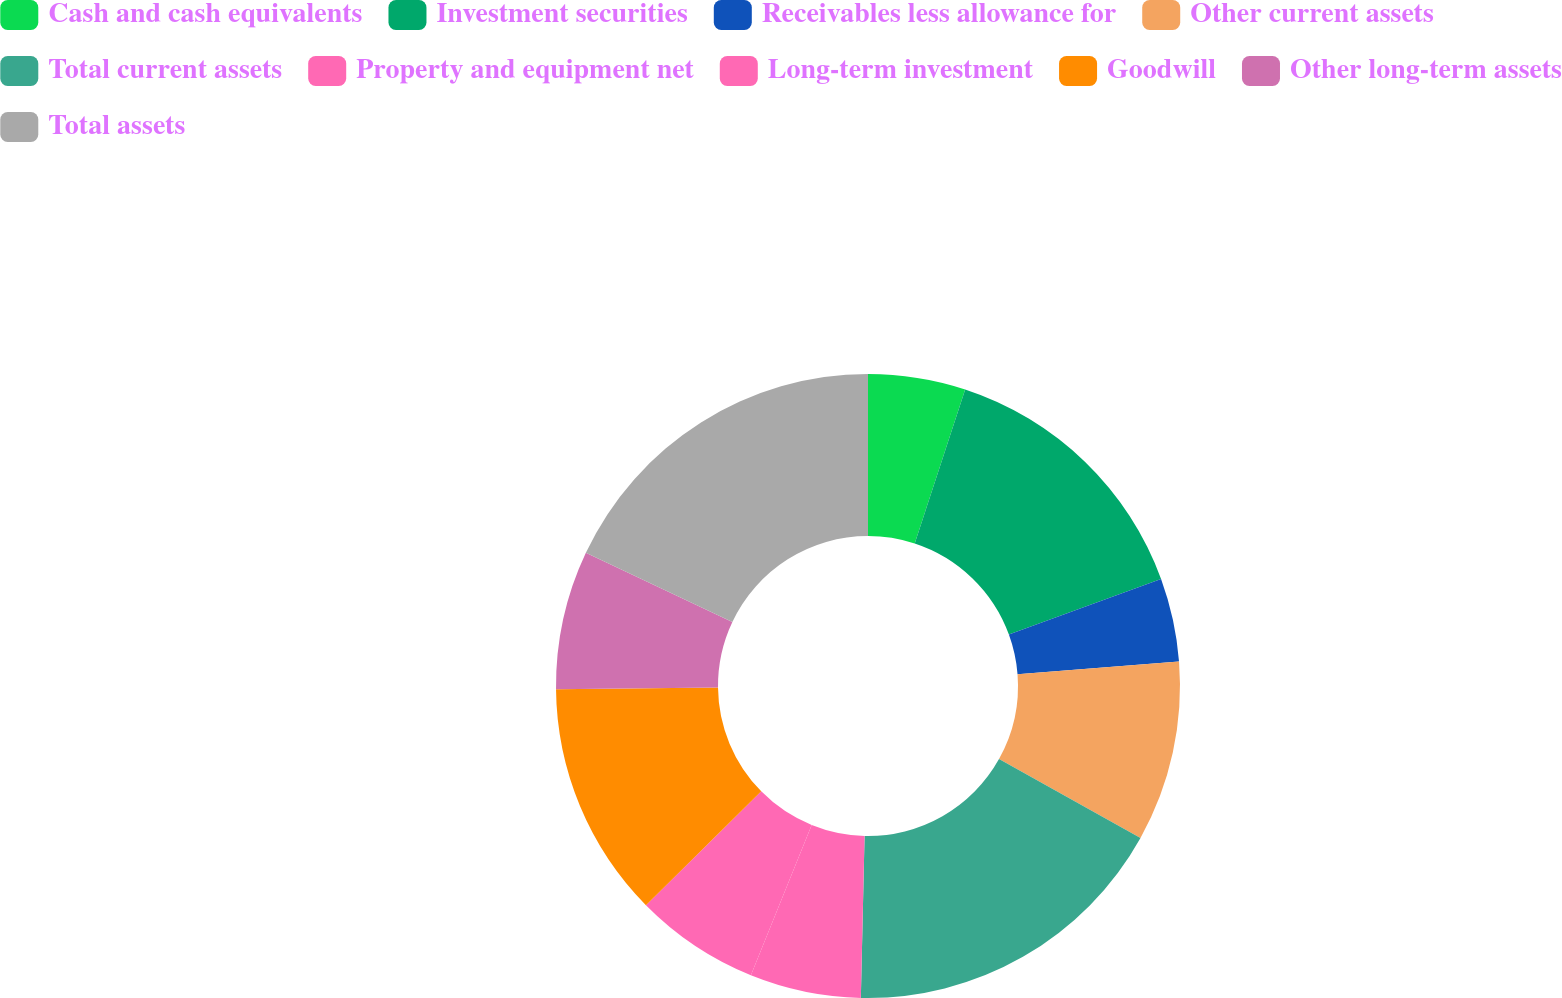Convert chart to OTSL. <chart><loc_0><loc_0><loc_500><loc_500><pie_chart><fcel>Cash and cash equivalents<fcel>Investment securities<fcel>Receivables less allowance for<fcel>Other current assets<fcel>Total current assets<fcel>Property and equipment net<fcel>Long-term investment<fcel>Goodwill<fcel>Other long-term assets<fcel>Total assets<nl><fcel>5.04%<fcel>14.39%<fcel>4.32%<fcel>9.35%<fcel>17.27%<fcel>5.76%<fcel>6.48%<fcel>12.23%<fcel>7.19%<fcel>17.98%<nl></chart> 